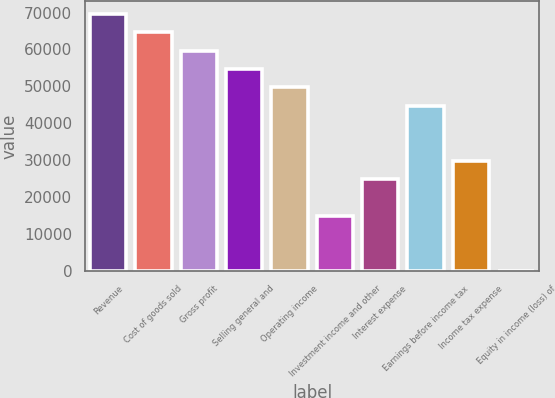Convert chart. <chart><loc_0><loc_0><loc_500><loc_500><bar_chart><fcel>Revenue<fcel>Cost of goods sold<fcel>Gross profit<fcel>Selling general and<fcel>Operating income<fcel>Investment income and other<fcel>Interest expense<fcel>Earnings before income tax<fcel>Income tax expense<fcel>Equity in income (loss) of<nl><fcel>69571.2<fcel>64601.9<fcel>59632.6<fcel>54663.3<fcel>49694<fcel>14908.9<fcel>24847.5<fcel>44724.7<fcel>29816.8<fcel>1<nl></chart> 